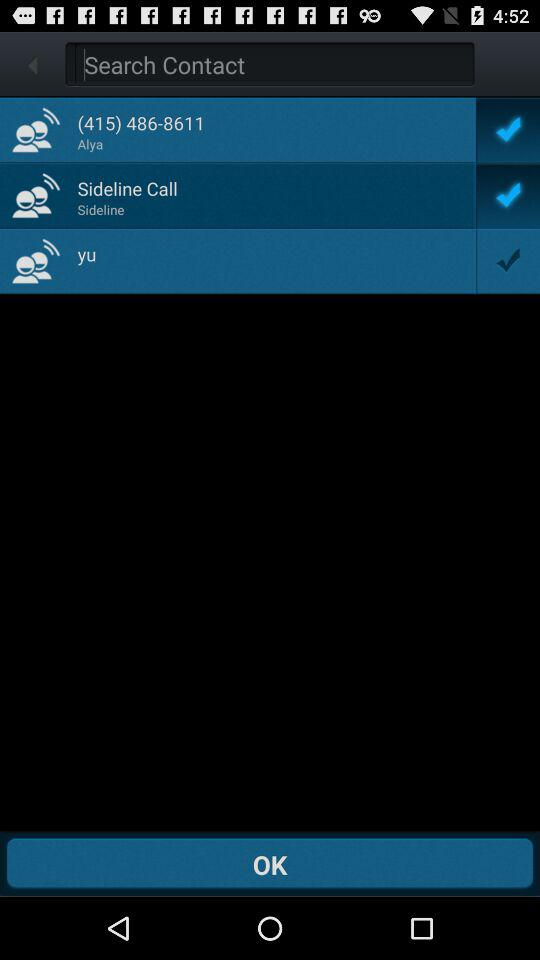What's the status of "Sideline Call"? The status is "on". 